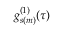<formula> <loc_0><loc_0><loc_500><loc_500>g _ { s ( m ) } ^ { ( 1 ) } ( \tau )</formula> 